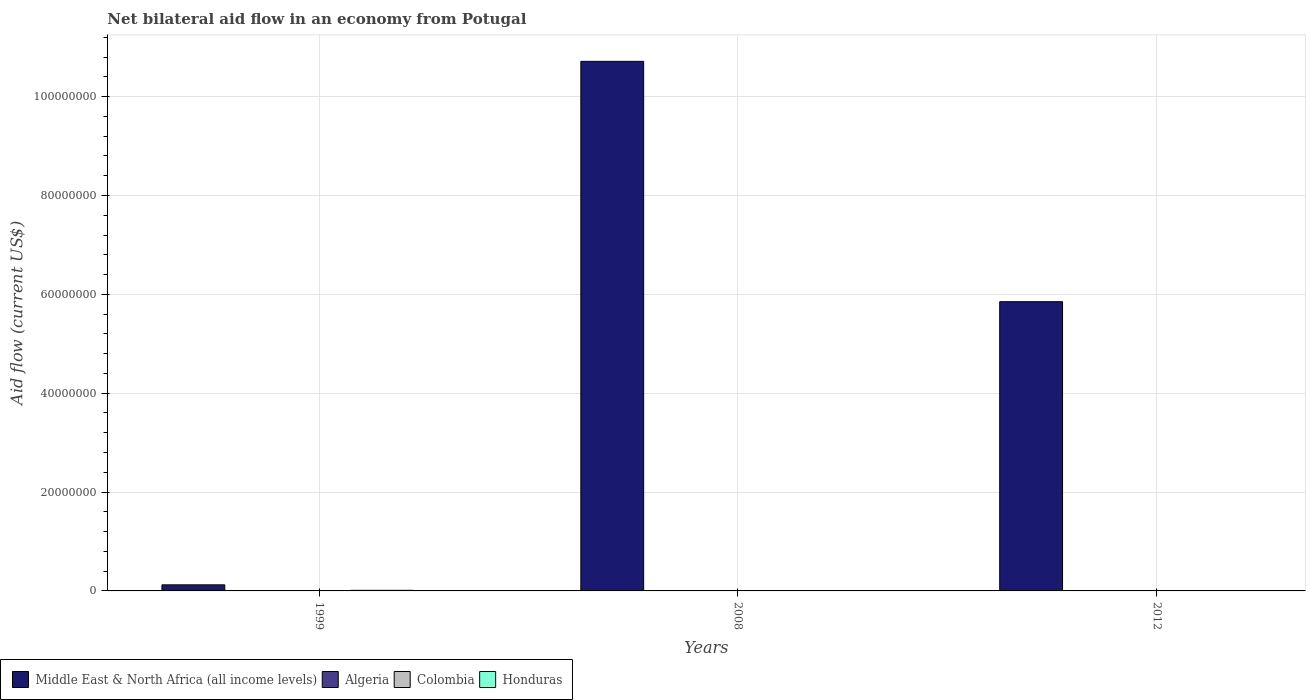How many different coloured bars are there?
Ensure brevity in your answer.  4. How many groups of bars are there?
Your answer should be very brief. 3. Are the number of bars on each tick of the X-axis equal?
Your answer should be very brief. Yes. How many bars are there on the 3rd tick from the left?
Make the answer very short. 4. In how many cases, is the number of bars for a given year not equal to the number of legend labels?
Provide a short and direct response. 0. Across all years, what is the maximum net bilateral aid flow in Middle East & North Africa (all income levels)?
Your response must be concise. 1.07e+08. Across all years, what is the minimum net bilateral aid flow in Algeria?
Provide a short and direct response. 2.00e+04. In which year was the net bilateral aid flow in Middle East & North Africa (all income levels) maximum?
Ensure brevity in your answer.  2008. In which year was the net bilateral aid flow in Honduras minimum?
Your answer should be very brief. 2012. What is the total net bilateral aid flow in Middle East & North Africa (all income levels) in the graph?
Offer a terse response. 1.67e+08. What is the average net bilateral aid flow in Middle East & North Africa (all income levels) per year?
Provide a succinct answer. 5.56e+07. In the year 2012, what is the difference between the net bilateral aid flow in Middle East & North Africa (all income levels) and net bilateral aid flow in Colombia?
Keep it short and to the point. 5.84e+07. In how many years, is the net bilateral aid flow in Colombia greater than 16000000 US$?
Ensure brevity in your answer.  0. What is the ratio of the net bilateral aid flow in Algeria in 1999 to that in 2008?
Ensure brevity in your answer.  1.33. In how many years, is the net bilateral aid flow in Honduras greater than the average net bilateral aid flow in Honduras taken over all years?
Your answer should be very brief. 1. Is it the case that in every year, the sum of the net bilateral aid flow in Algeria and net bilateral aid flow in Honduras is greater than the sum of net bilateral aid flow in Middle East & North Africa (all income levels) and net bilateral aid flow in Colombia?
Ensure brevity in your answer.  No. What does the 2nd bar from the right in 2008 represents?
Your response must be concise. Colombia. Are all the bars in the graph horizontal?
Offer a terse response. No. What is the difference between two consecutive major ticks on the Y-axis?
Provide a succinct answer. 2.00e+07. Does the graph contain any zero values?
Your answer should be very brief. No. Where does the legend appear in the graph?
Keep it short and to the point. Bottom left. How many legend labels are there?
Ensure brevity in your answer.  4. How are the legend labels stacked?
Provide a short and direct response. Horizontal. What is the title of the graph?
Give a very brief answer. Net bilateral aid flow in an economy from Potugal. What is the Aid flow (current US$) in Middle East & North Africa (all income levels) in 1999?
Ensure brevity in your answer.  1.23e+06. What is the Aid flow (current US$) of Algeria in 1999?
Provide a short and direct response. 8.00e+04. What is the Aid flow (current US$) of Colombia in 1999?
Your answer should be very brief. 10000. What is the Aid flow (current US$) in Middle East & North Africa (all income levels) in 2008?
Give a very brief answer. 1.07e+08. What is the Aid flow (current US$) in Algeria in 2008?
Offer a terse response. 6.00e+04. What is the Aid flow (current US$) in Middle East & North Africa (all income levels) in 2012?
Make the answer very short. 5.85e+07. What is the Aid flow (current US$) of Honduras in 2012?
Make the answer very short. 10000. Across all years, what is the maximum Aid flow (current US$) in Middle East & North Africa (all income levels)?
Your answer should be compact. 1.07e+08. Across all years, what is the maximum Aid flow (current US$) of Algeria?
Your answer should be compact. 8.00e+04. Across all years, what is the maximum Aid flow (current US$) of Honduras?
Offer a terse response. 1.20e+05. Across all years, what is the minimum Aid flow (current US$) in Middle East & North Africa (all income levels)?
Ensure brevity in your answer.  1.23e+06. Across all years, what is the minimum Aid flow (current US$) of Colombia?
Give a very brief answer. 10000. What is the total Aid flow (current US$) in Middle East & North Africa (all income levels) in the graph?
Your answer should be compact. 1.67e+08. What is the total Aid flow (current US$) in Algeria in the graph?
Keep it short and to the point. 1.60e+05. What is the total Aid flow (current US$) of Colombia in the graph?
Make the answer very short. 1.20e+05. What is the difference between the Aid flow (current US$) of Middle East & North Africa (all income levels) in 1999 and that in 2008?
Offer a very short reply. -1.06e+08. What is the difference between the Aid flow (current US$) of Colombia in 1999 and that in 2008?
Provide a succinct answer. -3.00e+04. What is the difference between the Aid flow (current US$) in Middle East & North Africa (all income levels) in 1999 and that in 2012?
Ensure brevity in your answer.  -5.73e+07. What is the difference between the Aid flow (current US$) of Middle East & North Africa (all income levels) in 2008 and that in 2012?
Your answer should be compact. 4.86e+07. What is the difference between the Aid flow (current US$) in Algeria in 2008 and that in 2012?
Make the answer very short. 4.00e+04. What is the difference between the Aid flow (current US$) of Middle East & North Africa (all income levels) in 1999 and the Aid flow (current US$) of Algeria in 2008?
Your answer should be very brief. 1.17e+06. What is the difference between the Aid flow (current US$) of Middle East & North Africa (all income levels) in 1999 and the Aid flow (current US$) of Colombia in 2008?
Give a very brief answer. 1.19e+06. What is the difference between the Aid flow (current US$) of Middle East & North Africa (all income levels) in 1999 and the Aid flow (current US$) of Honduras in 2008?
Your answer should be compact. 1.17e+06. What is the difference between the Aid flow (current US$) in Algeria in 1999 and the Aid flow (current US$) in Honduras in 2008?
Keep it short and to the point. 2.00e+04. What is the difference between the Aid flow (current US$) of Middle East & North Africa (all income levels) in 1999 and the Aid flow (current US$) of Algeria in 2012?
Your answer should be compact. 1.21e+06. What is the difference between the Aid flow (current US$) of Middle East & North Africa (all income levels) in 1999 and the Aid flow (current US$) of Colombia in 2012?
Your answer should be compact. 1.16e+06. What is the difference between the Aid flow (current US$) in Middle East & North Africa (all income levels) in 1999 and the Aid flow (current US$) in Honduras in 2012?
Your answer should be very brief. 1.22e+06. What is the difference between the Aid flow (current US$) of Algeria in 1999 and the Aid flow (current US$) of Honduras in 2012?
Offer a terse response. 7.00e+04. What is the difference between the Aid flow (current US$) in Middle East & North Africa (all income levels) in 2008 and the Aid flow (current US$) in Algeria in 2012?
Ensure brevity in your answer.  1.07e+08. What is the difference between the Aid flow (current US$) in Middle East & North Africa (all income levels) in 2008 and the Aid flow (current US$) in Colombia in 2012?
Your answer should be very brief. 1.07e+08. What is the difference between the Aid flow (current US$) of Middle East & North Africa (all income levels) in 2008 and the Aid flow (current US$) of Honduras in 2012?
Ensure brevity in your answer.  1.07e+08. What is the difference between the Aid flow (current US$) in Algeria in 2008 and the Aid flow (current US$) in Colombia in 2012?
Give a very brief answer. -10000. What is the difference between the Aid flow (current US$) of Algeria in 2008 and the Aid flow (current US$) of Honduras in 2012?
Your response must be concise. 5.00e+04. What is the average Aid flow (current US$) in Middle East & North Africa (all income levels) per year?
Offer a very short reply. 5.56e+07. What is the average Aid flow (current US$) of Algeria per year?
Keep it short and to the point. 5.33e+04. What is the average Aid flow (current US$) of Colombia per year?
Keep it short and to the point. 4.00e+04. What is the average Aid flow (current US$) in Honduras per year?
Provide a short and direct response. 6.33e+04. In the year 1999, what is the difference between the Aid flow (current US$) of Middle East & North Africa (all income levels) and Aid flow (current US$) of Algeria?
Keep it short and to the point. 1.15e+06. In the year 1999, what is the difference between the Aid flow (current US$) of Middle East & North Africa (all income levels) and Aid flow (current US$) of Colombia?
Offer a very short reply. 1.22e+06. In the year 1999, what is the difference between the Aid flow (current US$) in Middle East & North Africa (all income levels) and Aid flow (current US$) in Honduras?
Offer a terse response. 1.11e+06. In the year 1999, what is the difference between the Aid flow (current US$) in Algeria and Aid flow (current US$) in Colombia?
Keep it short and to the point. 7.00e+04. In the year 1999, what is the difference between the Aid flow (current US$) in Algeria and Aid flow (current US$) in Honduras?
Offer a terse response. -4.00e+04. In the year 2008, what is the difference between the Aid flow (current US$) in Middle East & North Africa (all income levels) and Aid flow (current US$) in Algeria?
Provide a succinct answer. 1.07e+08. In the year 2008, what is the difference between the Aid flow (current US$) of Middle East & North Africa (all income levels) and Aid flow (current US$) of Colombia?
Make the answer very short. 1.07e+08. In the year 2008, what is the difference between the Aid flow (current US$) in Middle East & North Africa (all income levels) and Aid flow (current US$) in Honduras?
Your answer should be very brief. 1.07e+08. In the year 2008, what is the difference between the Aid flow (current US$) of Algeria and Aid flow (current US$) of Honduras?
Keep it short and to the point. 0. In the year 2012, what is the difference between the Aid flow (current US$) of Middle East & North Africa (all income levels) and Aid flow (current US$) of Algeria?
Offer a very short reply. 5.85e+07. In the year 2012, what is the difference between the Aid flow (current US$) of Middle East & North Africa (all income levels) and Aid flow (current US$) of Colombia?
Make the answer very short. 5.84e+07. In the year 2012, what is the difference between the Aid flow (current US$) in Middle East & North Africa (all income levels) and Aid flow (current US$) in Honduras?
Ensure brevity in your answer.  5.85e+07. In the year 2012, what is the difference between the Aid flow (current US$) of Algeria and Aid flow (current US$) of Honduras?
Offer a very short reply. 10000. In the year 2012, what is the difference between the Aid flow (current US$) in Colombia and Aid flow (current US$) in Honduras?
Give a very brief answer. 6.00e+04. What is the ratio of the Aid flow (current US$) of Middle East & North Africa (all income levels) in 1999 to that in 2008?
Give a very brief answer. 0.01. What is the ratio of the Aid flow (current US$) of Honduras in 1999 to that in 2008?
Your response must be concise. 2. What is the ratio of the Aid flow (current US$) in Middle East & North Africa (all income levels) in 1999 to that in 2012?
Keep it short and to the point. 0.02. What is the ratio of the Aid flow (current US$) in Colombia in 1999 to that in 2012?
Your answer should be very brief. 0.14. What is the ratio of the Aid flow (current US$) of Honduras in 1999 to that in 2012?
Give a very brief answer. 12. What is the ratio of the Aid flow (current US$) of Middle East & North Africa (all income levels) in 2008 to that in 2012?
Your response must be concise. 1.83. What is the ratio of the Aid flow (current US$) in Honduras in 2008 to that in 2012?
Provide a short and direct response. 6. What is the difference between the highest and the second highest Aid flow (current US$) of Middle East & North Africa (all income levels)?
Offer a terse response. 4.86e+07. What is the difference between the highest and the second highest Aid flow (current US$) in Algeria?
Give a very brief answer. 2.00e+04. What is the difference between the highest and the second highest Aid flow (current US$) in Colombia?
Offer a terse response. 3.00e+04. What is the difference between the highest and the second highest Aid flow (current US$) of Honduras?
Ensure brevity in your answer.  6.00e+04. What is the difference between the highest and the lowest Aid flow (current US$) of Middle East & North Africa (all income levels)?
Ensure brevity in your answer.  1.06e+08. What is the difference between the highest and the lowest Aid flow (current US$) of Honduras?
Your response must be concise. 1.10e+05. 